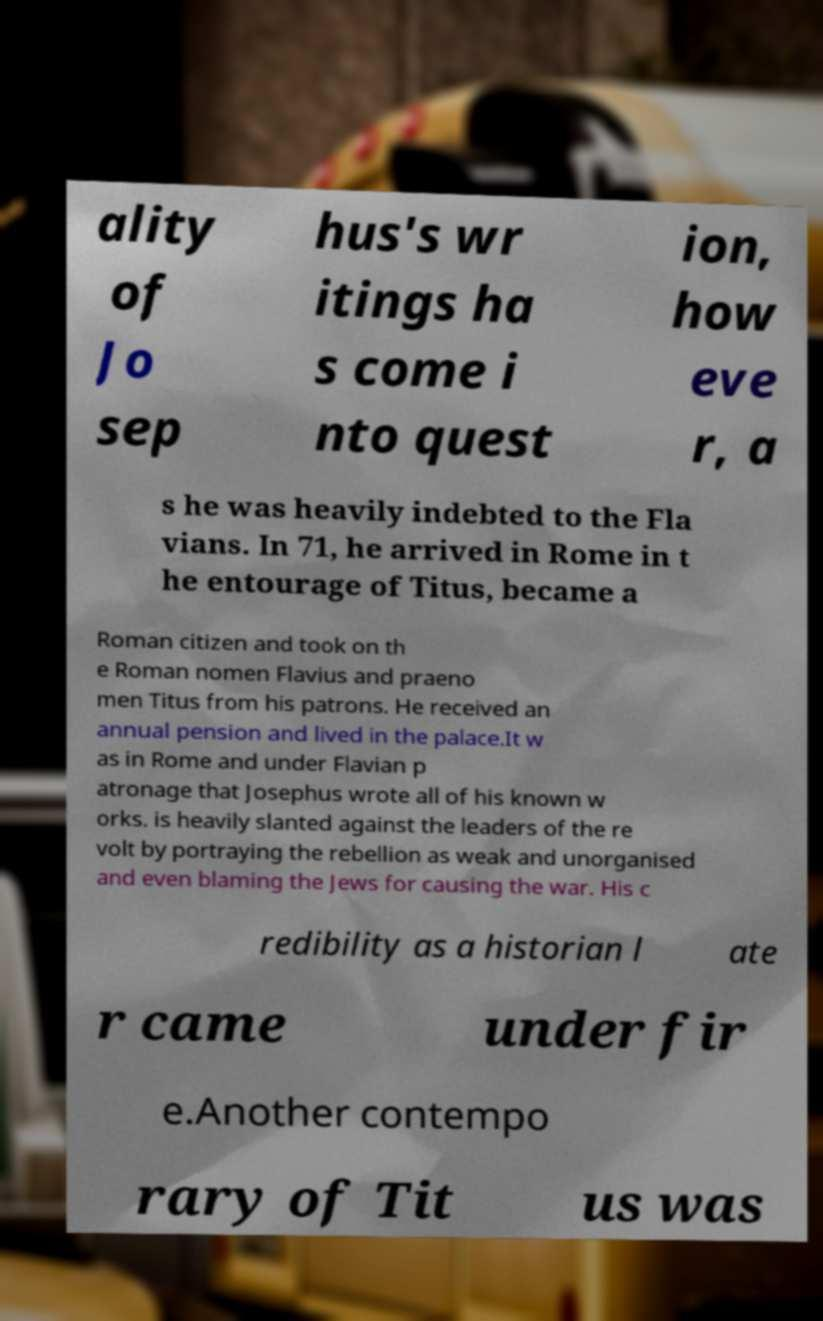Can you accurately transcribe the text from the provided image for me? ality of Jo sep hus's wr itings ha s come i nto quest ion, how eve r, a s he was heavily indebted to the Fla vians. In 71, he arrived in Rome in t he entourage of Titus, became a Roman citizen and took on th e Roman nomen Flavius and praeno men Titus from his patrons. He received an annual pension and lived in the palace.It w as in Rome and under Flavian p atronage that Josephus wrote all of his known w orks. is heavily slanted against the leaders of the re volt by portraying the rebellion as weak and unorganised and even blaming the Jews for causing the war. His c redibility as a historian l ate r came under fir e.Another contempo rary of Tit us was 